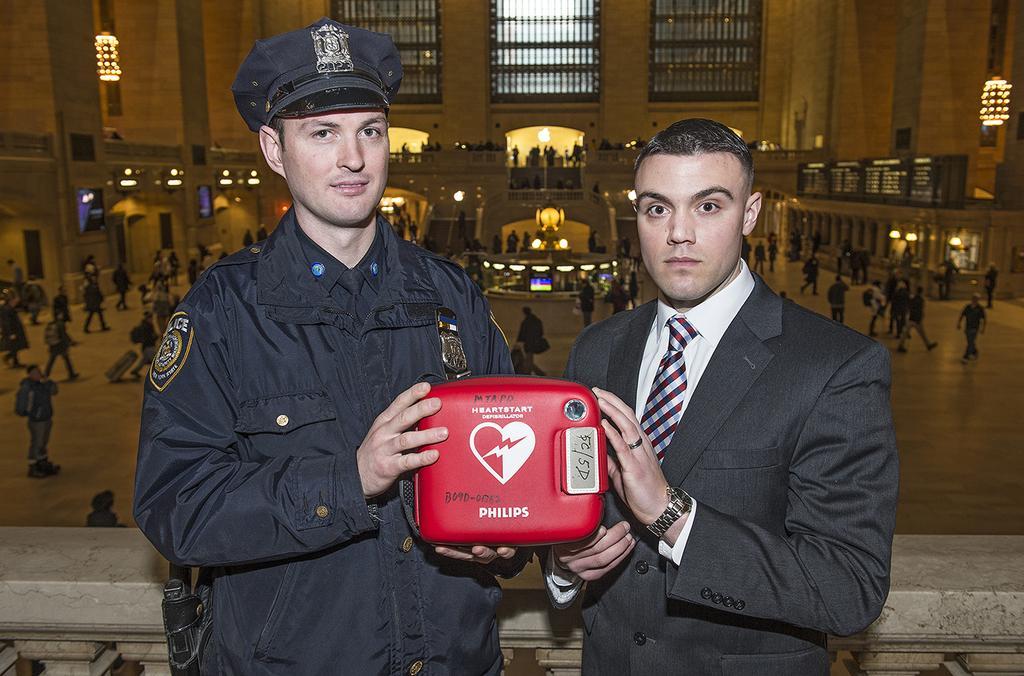Describe this image in one or two sentences. In this picture we can see two men are standing and holding some machine with their hands and in the background we can see some more persons walking, wall, light, balcony and on left side person is smiling. 